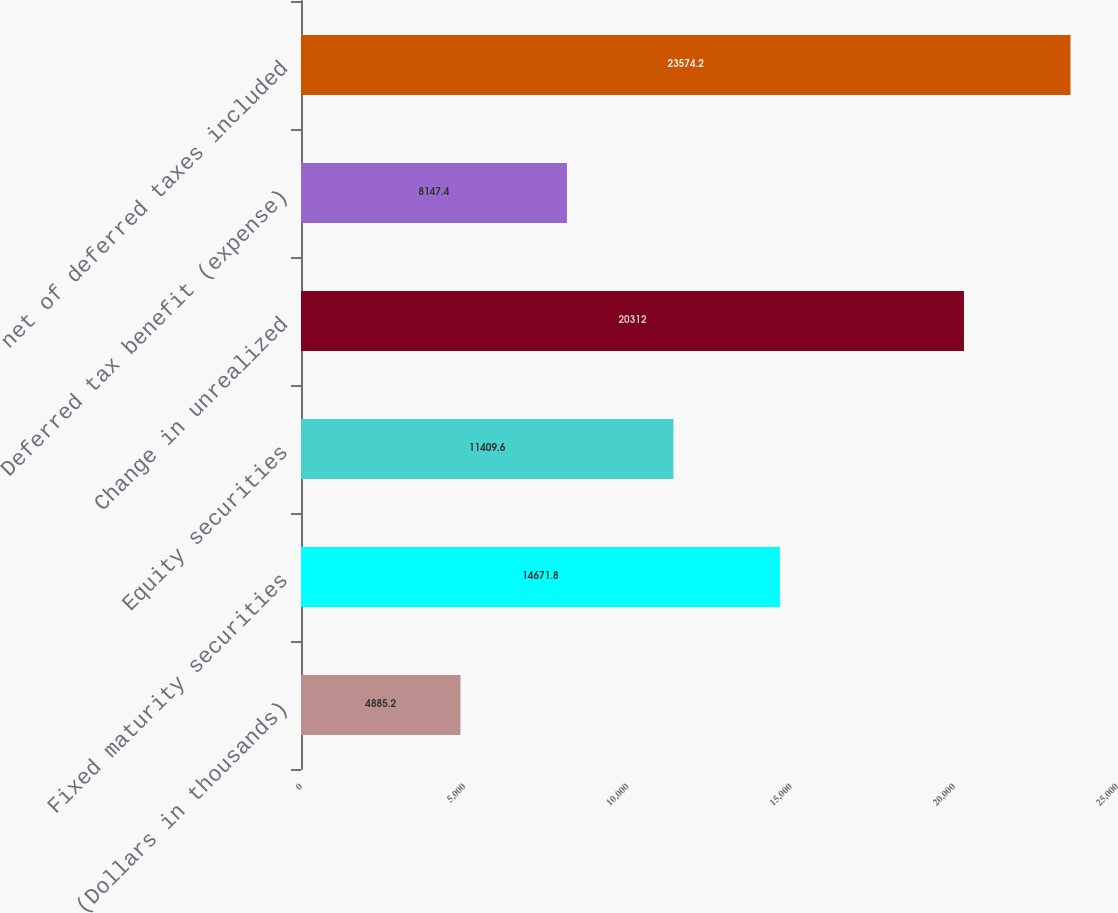<chart> <loc_0><loc_0><loc_500><loc_500><bar_chart><fcel>(Dollars in thousands)<fcel>Fixed maturity securities<fcel>Equity securities<fcel>Change in unrealized<fcel>Deferred tax benefit (expense)<fcel>net of deferred taxes included<nl><fcel>4885.2<fcel>14671.8<fcel>11409.6<fcel>20312<fcel>8147.4<fcel>23574.2<nl></chart> 